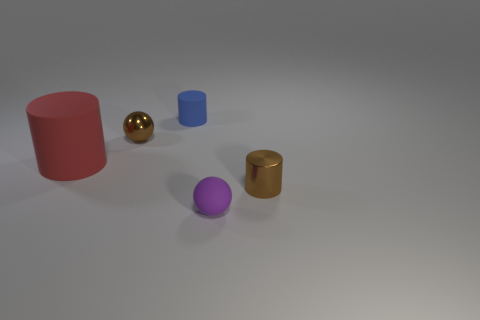Are there any large yellow cylinders? no 